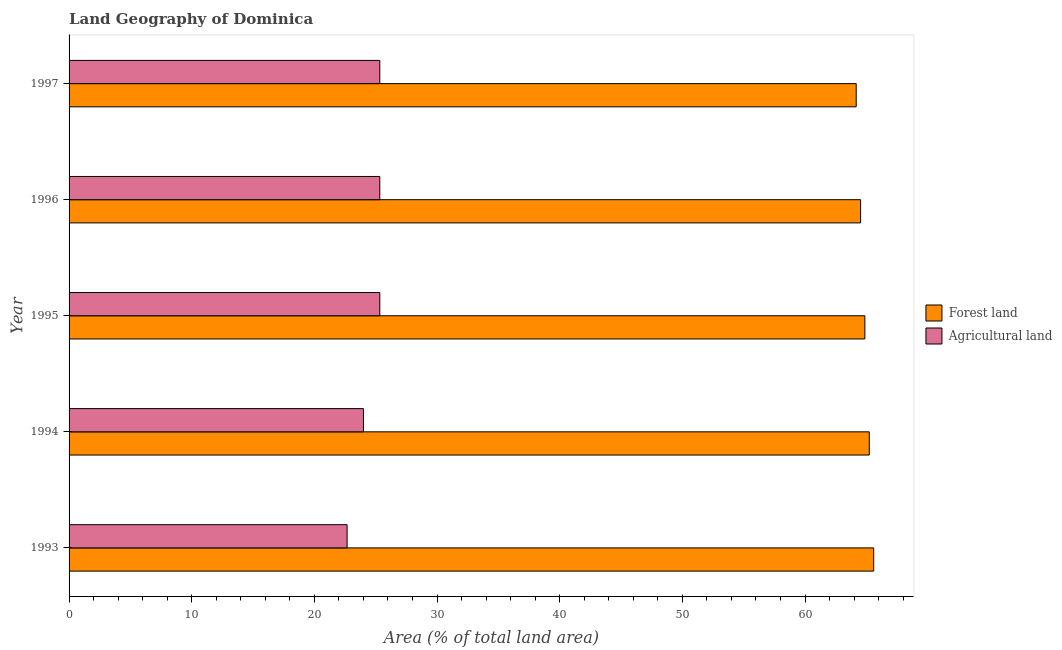How many different coloured bars are there?
Provide a succinct answer. 2. What is the label of the 2nd group of bars from the top?
Give a very brief answer. 1996. What is the percentage of land area under forests in 1995?
Keep it short and to the point. 64.88. Across all years, what is the maximum percentage of land area under forests?
Provide a succinct answer. 65.6. Across all years, what is the minimum percentage of land area under agriculture?
Ensure brevity in your answer.  22.67. In which year was the percentage of land area under agriculture maximum?
Keep it short and to the point. 1995. What is the total percentage of land area under agriculture in the graph?
Your response must be concise. 122.67. What is the difference between the percentage of land area under forests in 1995 and that in 1996?
Give a very brief answer. 0.35. What is the difference between the percentage of land area under agriculture in 1993 and the percentage of land area under forests in 1997?
Offer a very short reply. -41.51. What is the average percentage of land area under forests per year?
Make the answer very short. 64.89. In the year 1993, what is the difference between the percentage of land area under forests and percentage of land area under agriculture?
Your answer should be compact. 42.93. In how many years, is the percentage of land area under agriculture greater than 46 %?
Your answer should be very brief. 0. What is the ratio of the percentage of land area under agriculture in 1993 to that in 1995?
Ensure brevity in your answer.  0.9. Is the percentage of land area under agriculture in 1993 less than that in 1997?
Your answer should be very brief. Yes. What is the difference between the highest and the lowest percentage of land area under agriculture?
Offer a terse response. 2.67. In how many years, is the percentage of land area under agriculture greater than the average percentage of land area under agriculture taken over all years?
Your answer should be compact. 3. Is the sum of the percentage of land area under agriculture in 1995 and 1996 greater than the maximum percentage of land area under forests across all years?
Your answer should be compact. No. What does the 1st bar from the top in 1993 represents?
Your answer should be compact. Agricultural land. What does the 1st bar from the bottom in 1994 represents?
Offer a very short reply. Forest land. How many bars are there?
Give a very brief answer. 10. What is the difference between two consecutive major ticks on the X-axis?
Your answer should be compact. 10. Are the values on the major ticks of X-axis written in scientific E-notation?
Provide a succinct answer. No. How are the legend labels stacked?
Provide a succinct answer. Vertical. What is the title of the graph?
Your answer should be compact. Land Geography of Dominica. What is the label or title of the X-axis?
Provide a succinct answer. Area (% of total land area). What is the Area (% of total land area) of Forest land in 1993?
Provide a short and direct response. 65.6. What is the Area (% of total land area) of Agricultural land in 1993?
Ensure brevity in your answer.  22.67. What is the Area (% of total land area) of Forest land in 1994?
Offer a very short reply. 65.24. What is the Area (% of total land area) of Agricultural land in 1994?
Offer a terse response. 24. What is the Area (% of total land area) in Forest land in 1995?
Your answer should be very brief. 64.88. What is the Area (% of total land area) of Agricultural land in 1995?
Provide a succinct answer. 25.33. What is the Area (% of total land area) of Forest land in 1996?
Offer a very short reply. 64.53. What is the Area (% of total land area) in Agricultural land in 1996?
Offer a terse response. 25.33. What is the Area (% of total land area) in Forest land in 1997?
Your answer should be very brief. 64.17. What is the Area (% of total land area) of Agricultural land in 1997?
Provide a succinct answer. 25.33. Across all years, what is the maximum Area (% of total land area) in Forest land?
Make the answer very short. 65.6. Across all years, what is the maximum Area (% of total land area) of Agricultural land?
Ensure brevity in your answer.  25.33. Across all years, what is the minimum Area (% of total land area) of Forest land?
Offer a very short reply. 64.17. Across all years, what is the minimum Area (% of total land area) in Agricultural land?
Ensure brevity in your answer.  22.67. What is the total Area (% of total land area) of Forest land in the graph?
Offer a very short reply. 324.43. What is the total Area (% of total land area) in Agricultural land in the graph?
Your answer should be very brief. 122.67. What is the difference between the Area (% of total land area) of Forest land in 1993 and that in 1994?
Offer a very short reply. 0.36. What is the difference between the Area (% of total land area) of Agricultural land in 1993 and that in 1994?
Give a very brief answer. -1.33. What is the difference between the Area (% of total land area) of Forest land in 1993 and that in 1995?
Ensure brevity in your answer.  0.72. What is the difference between the Area (% of total land area) of Agricultural land in 1993 and that in 1995?
Offer a very short reply. -2.67. What is the difference between the Area (% of total land area) in Forest land in 1993 and that in 1996?
Your answer should be very brief. 1.07. What is the difference between the Area (% of total land area) in Agricultural land in 1993 and that in 1996?
Offer a very short reply. -2.67. What is the difference between the Area (% of total land area) in Forest land in 1993 and that in 1997?
Keep it short and to the point. 1.43. What is the difference between the Area (% of total land area) in Agricultural land in 1993 and that in 1997?
Keep it short and to the point. -2.67. What is the difference between the Area (% of total land area) in Forest land in 1994 and that in 1995?
Your response must be concise. 0.36. What is the difference between the Area (% of total land area) in Agricultural land in 1994 and that in 1995?
Offer a very short reply. -1.33. What is the difference between the Area (% of total land area) of Forest land in 1994 and that in 1996?
Your response must be concise. 0.71. What is the difference between the Area (% of total land area) of Agricultural land in 1994 and that in 1996?
Your answer should be compact. -1.33. What is the difference between the Area (% of total land area) in Forest land in 1994 and that in 1997?
Ensure brevity in your answer.  1.07. What is the difference between the Area (% of total land area) in Agricultural land in 1994 and that in 1997?
Give a very brief answer. -1.33. What is the difference between the Area (% of total land area) in Forest land in 1995 and that in 1996?
Offer a terse response. 0.35. What is the difference between the Area (% of total land area) in Forest land in 1995 and that in 1997?
Ensure brevity in your answer.  0.71. What is the difference between the Area (% of total land area) in Forest land in 1996 and that in 1997?
Your response must be concise. 0.36. What is the difference between the Area (% of total land area) in Agricultural land in 1996 and that in 1997?
Provide a short and direct response. 0. What is the difference between the Area (% of total land area) of Forest land in 1993 and the Area (% of total land area) of Agricultural land in 1994?
Provide a short and direct response. 41.6. What is the difference between the Area (% of total land area) of Forest land in 1993 and the Area (% of total land area) of Agricultural land in 1995?
Make the answer very short. 40.27. What is the difference between the Area (% of total land area) in Forest land in 1993 and the Area (% of total land area) in Agricultural land in 1996?
Your response must be concise. 40.27. What is the difference between the Area (% of total land area) in Forest land in 1993 and the Area (% of total land area) in Agricultural land in 1997?
Keep it short and to the point. 40.27. What is the difference between the Area (% of total land area) of Forest land in 1994 and the Area (% of total land area) of Agricultural land in 1995?
Provide a short and direct response. 39.91. What is the difference between the Area (% of total land area) of Forest land in 1994 and the Area (% of total land area) of Agricultural land in 1996?
Give a very brief answer. 39.91. What is the difference between the Area (% of total land area) in Forest land in 1994 and the Area (% of total land area) in Agricultural land in 1997?
Make the answer very short. 39.91. What is the difference between the Area (% of total land area) of Forest land in 1995 and the Area (% of total land area) of Agricultural land in 1996?
Offer a very short reply. 39.55. What is the difference between the Area (% of total land area) in Forest land in 1995 and the Area (% of total land area) in Agricultural land in 1997?
Your answer should be compact. 39.55. What is the difference between the Area (% of total land area) of Forest land in 1996 and the Area (% of total land area) of Agricultural land in 1997?
Offer a terse response. 39.2. What is the average Area (% of total land area) in Forest land per year?
Your answer should be compact. 64.89. What is the average Area (% of total land area) in Agricultural land per year?
Your response must be concise. 24.53. In the year 1993, what is the difference between the Area (% of total land area) of Forest land and Area (% of total land area) of Agricultural land?
Your answer should be very brief. 42.93. In the year 1994, what is the difference between the Area (% of total land area) in Forest land and Area (% of total land area) in Agricultural land?
Offer a terse response. 41.24. In the year 1995, what is the difference between the Area (% of total land area) in Forest land and Area (% of total land area) in Agricultural land?
Provide a short and direct response. 39.55. In the year 1996, what is the difference between the Area (% of total land area) in Forest land and Area (% of total land area) in Agricultural land?
Make the answer very short. 39.2. In the year 1997, what is the difference between the Area (% of total land area) of Forest land and Area (% of total land area) of Agricultural land?
Your answer should be compact. 38.84. What is the ratio of the Area (% of total land area) of Agricultural land in 1993 to that in 1994?
Your answer should be very brief. 0.94. What is the ratio of the Area (% of total land area) in Forest land in 1993 to that in 1995?
Offer a very short reply. 1.01. What is the ratio of the Area (% of total land area) in Agricultural land in 1993 to that in 1995?
Give a very brief answer. 0.89. What is the ratio of the Area (% of total land area) of Forest land in 1993 to that in 1996?
Offer a very short reply. 1.02. What is the ratio of the Area (% of total land area) in Agricultural land in 1993 to that in 1996?
Provide a short and direct response. 0.89. What is the ratio of the Area (% of total land area) of Forest land in 1993 to that in 1997?
Provide a succinct answer. 1.02. What is the ratio of the Area (% of total land area) in Agricultural land in 1993 to that in 1997?
Your response must be concise. 0.89. What is the ratio of the Area (% of total land area) in Agricultural land in 1994 to that in 1995?
Your response must be concise. 0.95. What is the ratio of the Area (% of total land area) of Forest land in 1994 to that in 1996?
Make the answer very short. 1.01. What is the ratio of the Area (% of total land area) in Agricultural land in 1994 to that in 1996?
Offer a very short reply. 0.95. What is the ratio of the Area (% of total land area) of Forest land in 1994 to that in 1997?
Your response must be concise. 1.02. What is the ratio of the Area (% of total land area) of Forest land in 1995 to that in 1996?
Offer a very short reply. 1.01. What is the ratio of the Area (% of total land area) of Agricultural land in 1995 to that in 1997?
Keep it short and to the point. 1. What is the ratio of the Area (% of total land area) of Forest land in 1996 to that in 1997?
Your answer should be compact. 1.01. What is the difference between the highest and the second highest Area (% of total land area) of Forest land?
Ensure brevity in your answer.  0.36. What is the difference between the highest and the lowest Area (% of total land area) in Forest land?
Provide a succinct answer. 1.43. What is the difference between the highest and the lowest Area (% of total land area) of Agricultural land?
Your answer should be very brief. 2.67. 